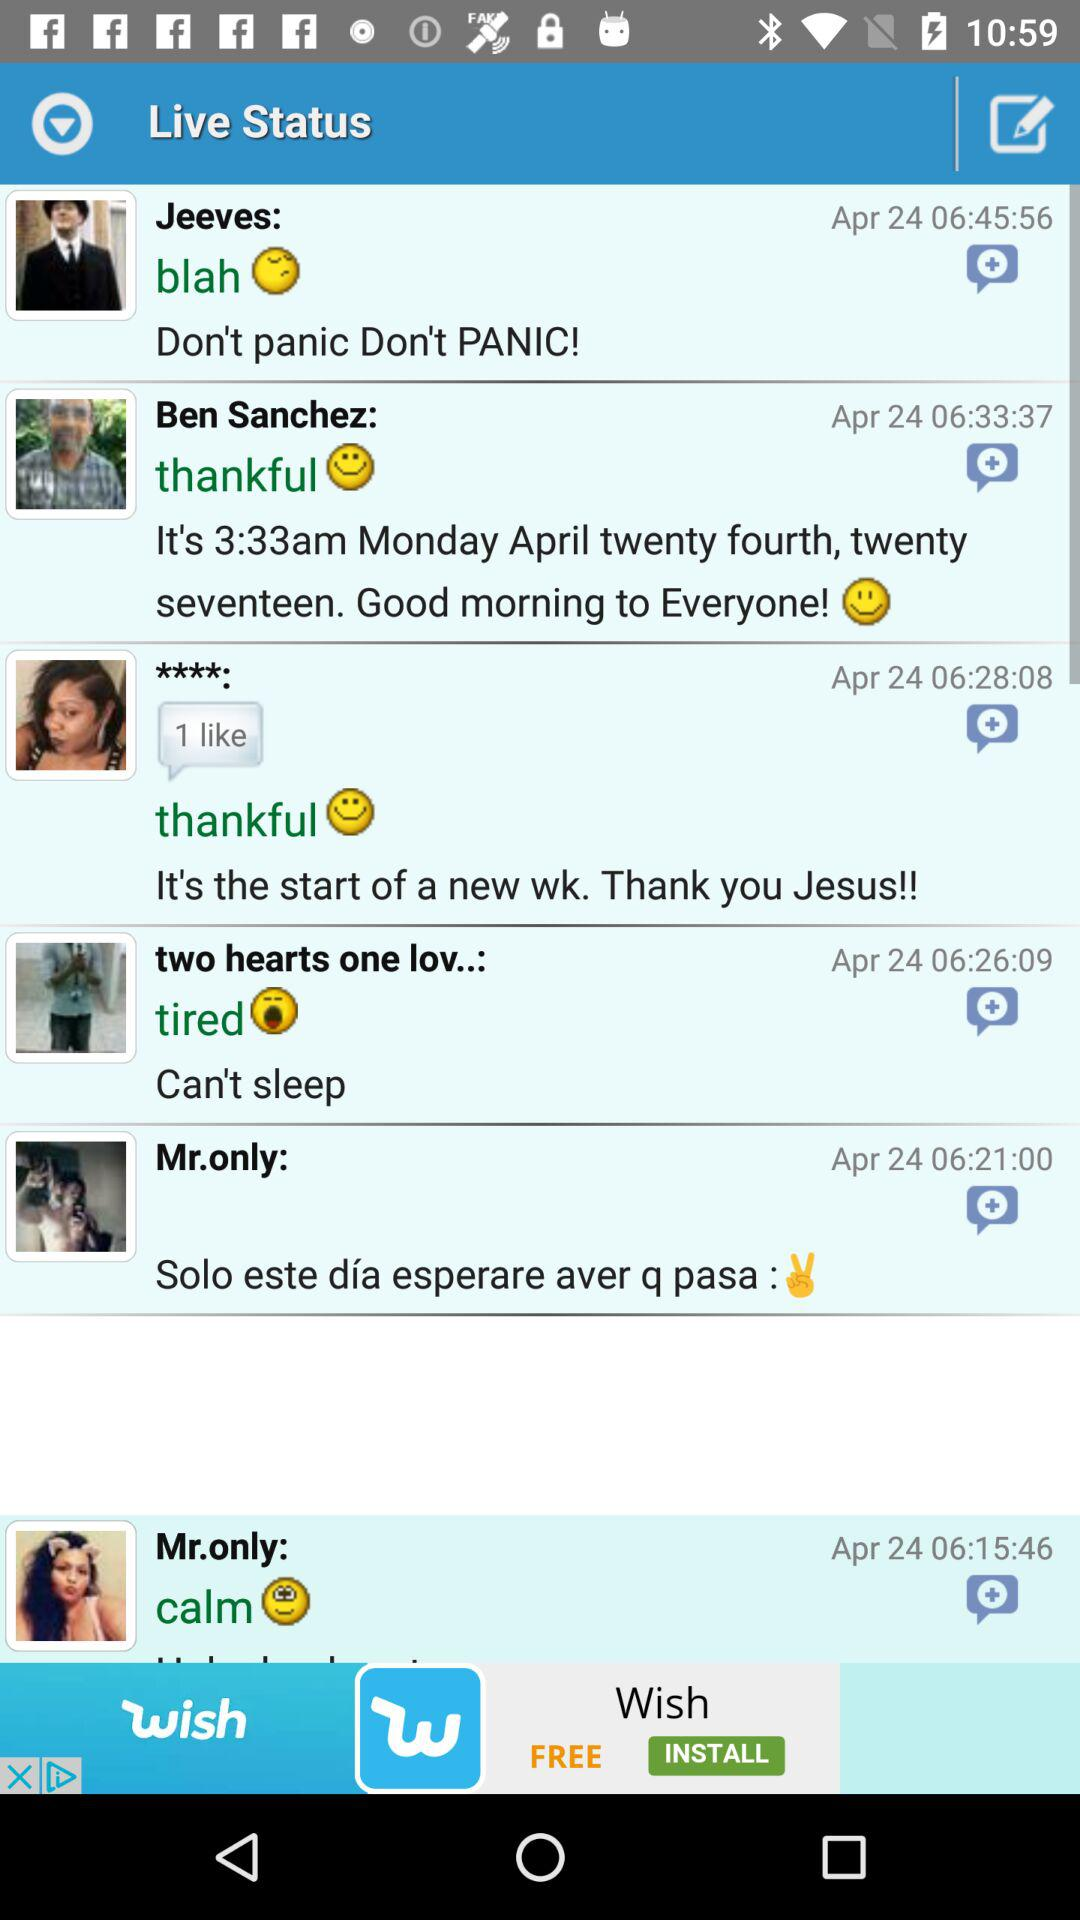What is the date? The date is April 24. 